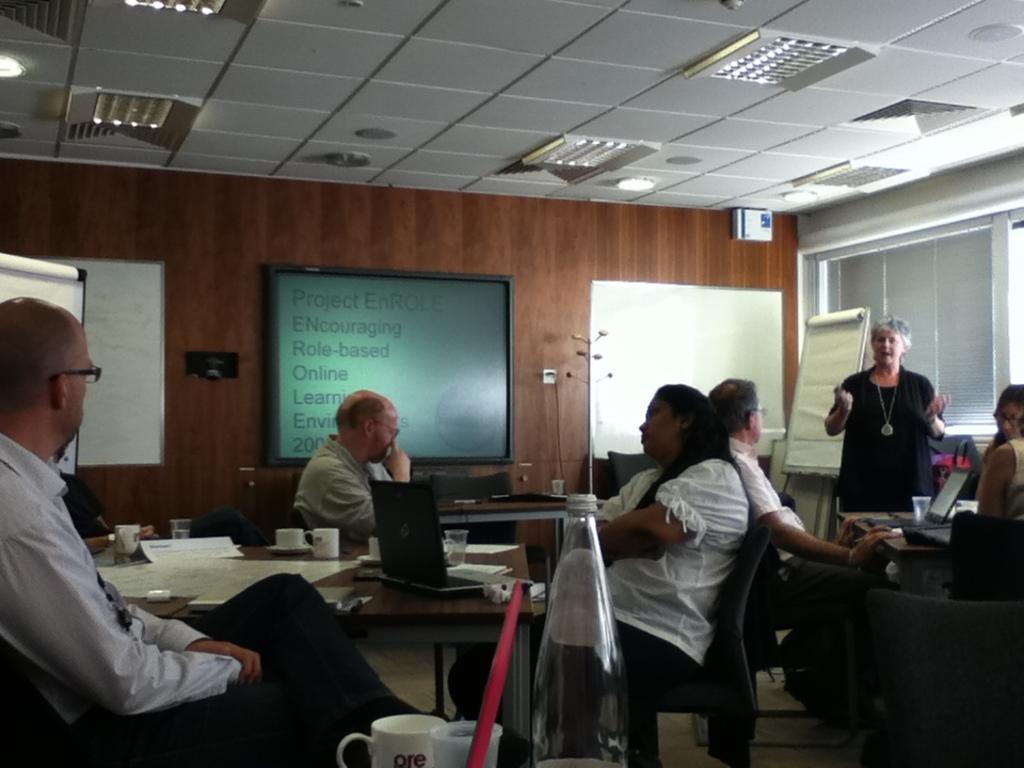How would you summarize this image in a sentence or two? The women in the right corner is standing and speaking in front of a group of people who are sitting in chairs and there is a table in front of them which has some laptops and some papers on it. 